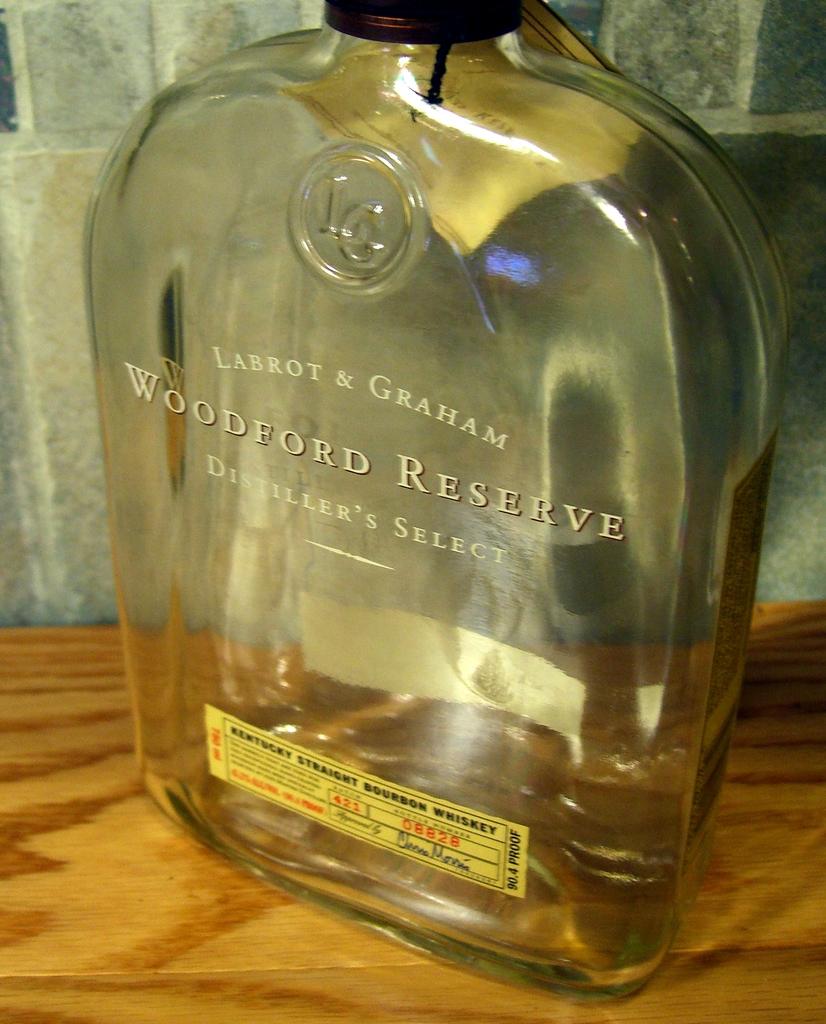Who makes this woodward reserve?
Offer a very short reply. Labrot & graham. What state was this whisky made in?
Provide a succinct answer. Kentucky. 